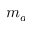<formula> <loc_0><loc_0><loc_500><loc_500>m _ { a }</formula> 